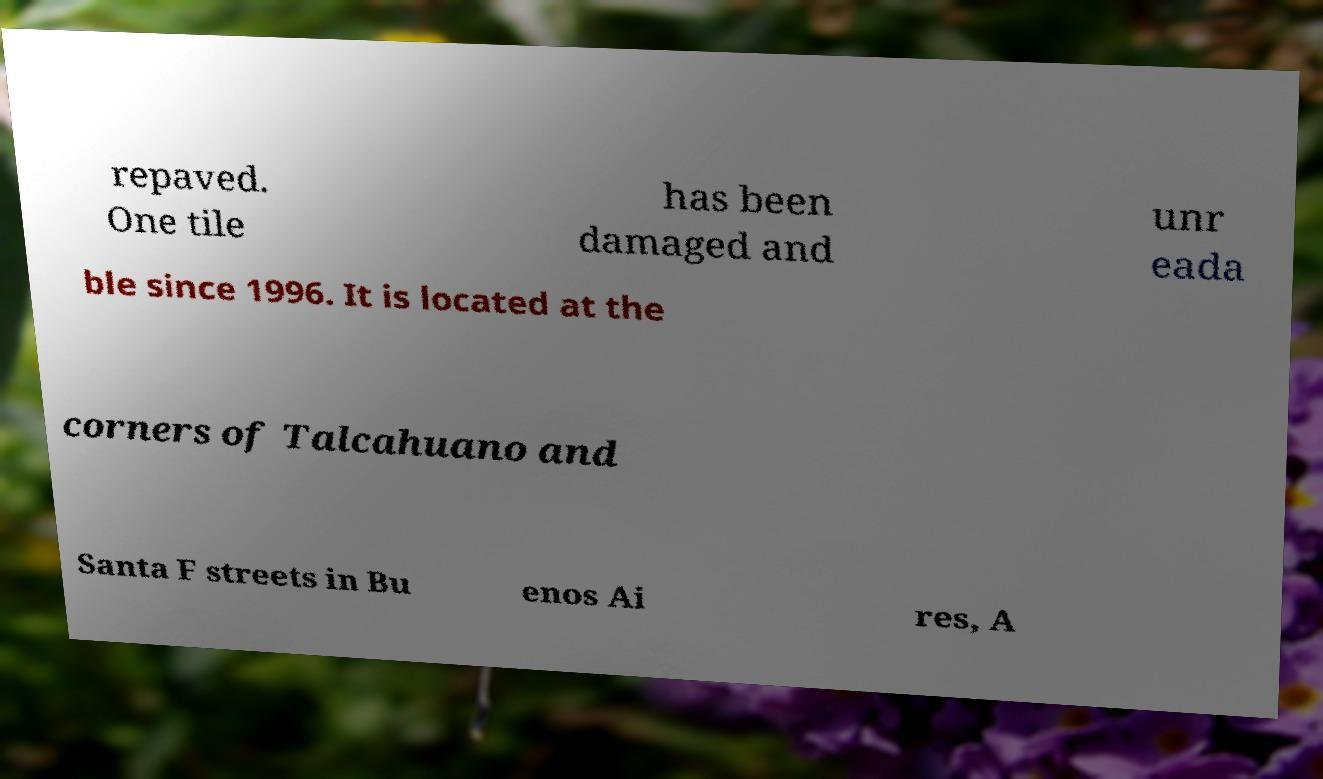What messages or text are displayed in this image? I need them in a readable, typed format. repaved. One tile has been damaged and unr eada ble since 1996. It is located at the corners of Talcahuano and Santa F streets in Bu enos Ai res, A 